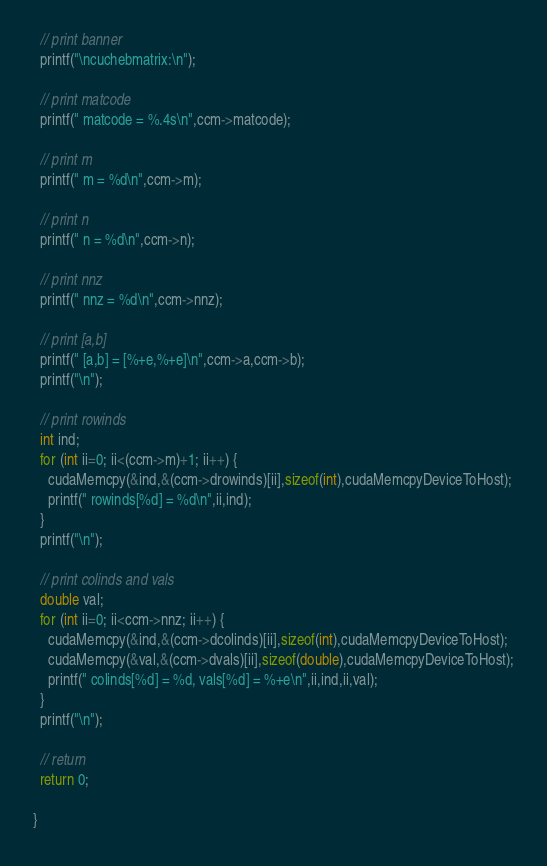<code> <loc_0><loc_0><loc_500><loc_500><_Cuda_>
  // print banner
  printf("\ncuchebmatrix:\n");

  // print matcode
  printf(" matcode = %.4s\n",ccm->matcode);
 
  // print m
  printf(" m = %d\n",ccm->m);
 
  // print n
  printf(" n = %d\n",ccm->n);
 
  // print nnz
  printf(" nnz = %d\n",ccm->nnz);
 
  // print [a,b]
  printf(" [a,b] = [%+e,%+e]\n",ccm->a,ccm->b);
  printf("\n");

  // print rowinds
  int ind;
  for (int ii=0; ii<(ccm->m)+1; ii++) {
    cudaMemcpy(&ind,&(ccm->drowinds)[ii],sizeof(int),cudaMemcpyDeviceToHost);
    printf(" rowinds[%d] = %d\n",ii,ind);
  }
  printf("\n");

  // print colinds and vals
  double val;
  for (int ii=0; ii<ccm->nnz; ii++) {
    cudaMemcpy(&ind,&(ccm->dcolinds)[ii],sizeof(int),cudaMemcpyDeviceToHost);
    cudaMemcpy(&val,&(ccm->dvals)[ii],sizeof(double),cudaMemcpyDeviceToHost);
    printf(" colinds[%d] = %d, vals[%d] = %+e\n",ii,ind,ii,val);
  }
  printf("\n");

  // return 
  return 0;

}

</code> 